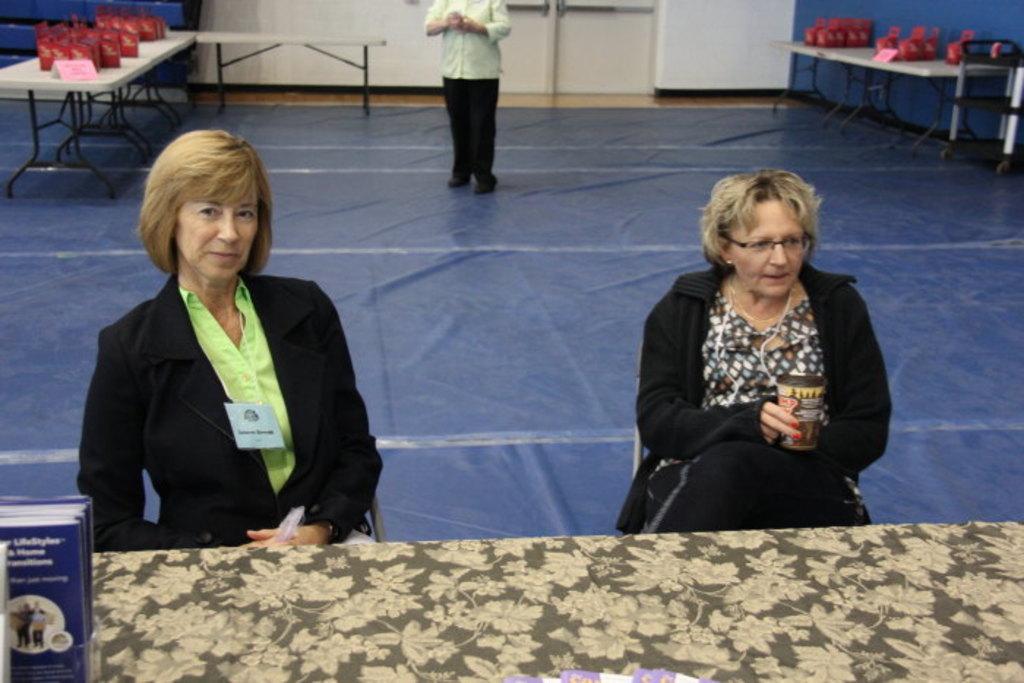Describe this image in one or two sentences. In this image there are two persons sitting on the chair. In front of them there is a table and on top of the table there are few objects. At the bottom of the surface there is a carpet. At the center of the image there is a person standing on the carpet. On both right and left side of the image there are tables and on top of the table there are few objects. On the backside there is a blue wall. 